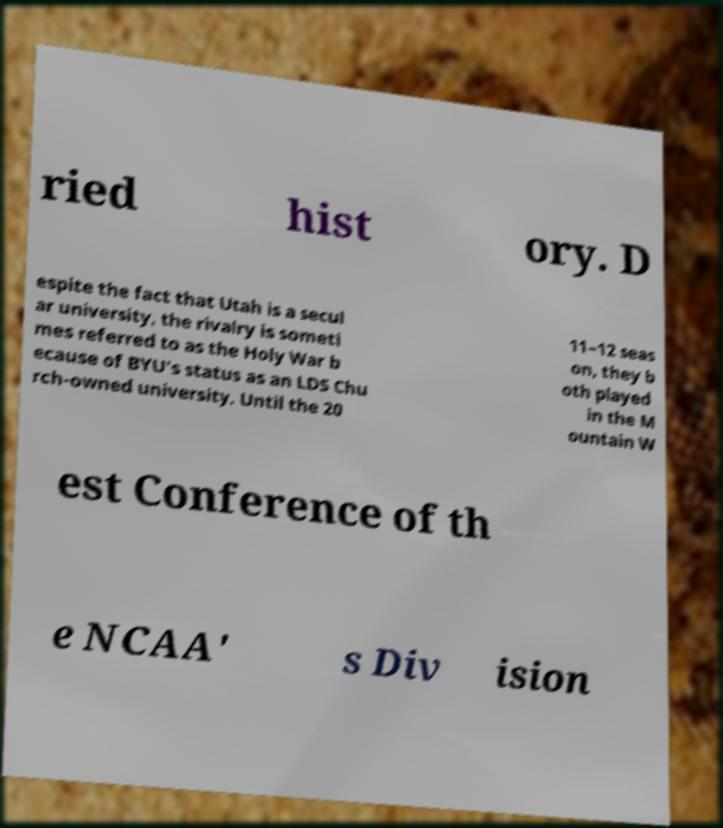Can you read and provide the text displayed in the image?This photo seems to have some interesting text. Can you extract and type it out for me? ried hist ory. D espite the fact that Utah is a secul ar university, the rivalry is someti mes referred to as the Holy War b ecause of BYU's status as an LDS Chu rch-owned university. Until the 20 11–12 seas on, they b oth played in the M ountain W est Conference of th e NCAA' s Div ision 